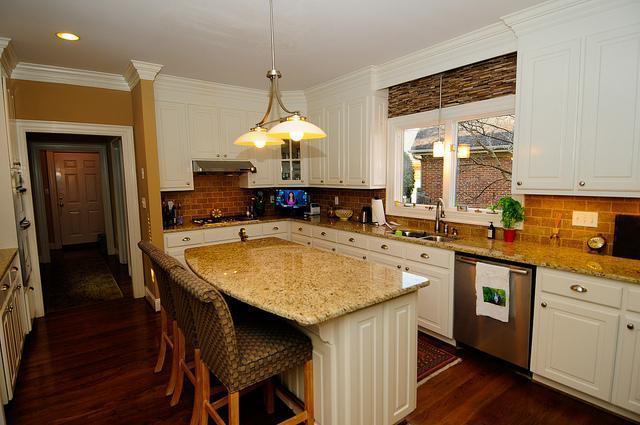How many chairs are there?
Give a very brief answer. 2. How many dining tables are visible?
Give a very brief answer. 1. How many boat on the seasore?
Give a very brief answer. 0. 